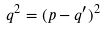Convert formula to latex. <formula><loc_0><loc_0><loc_500><loc_500>q ^ { 2 } = ( p - q ^ { \prime } ) ^ { 2 }</formula> 